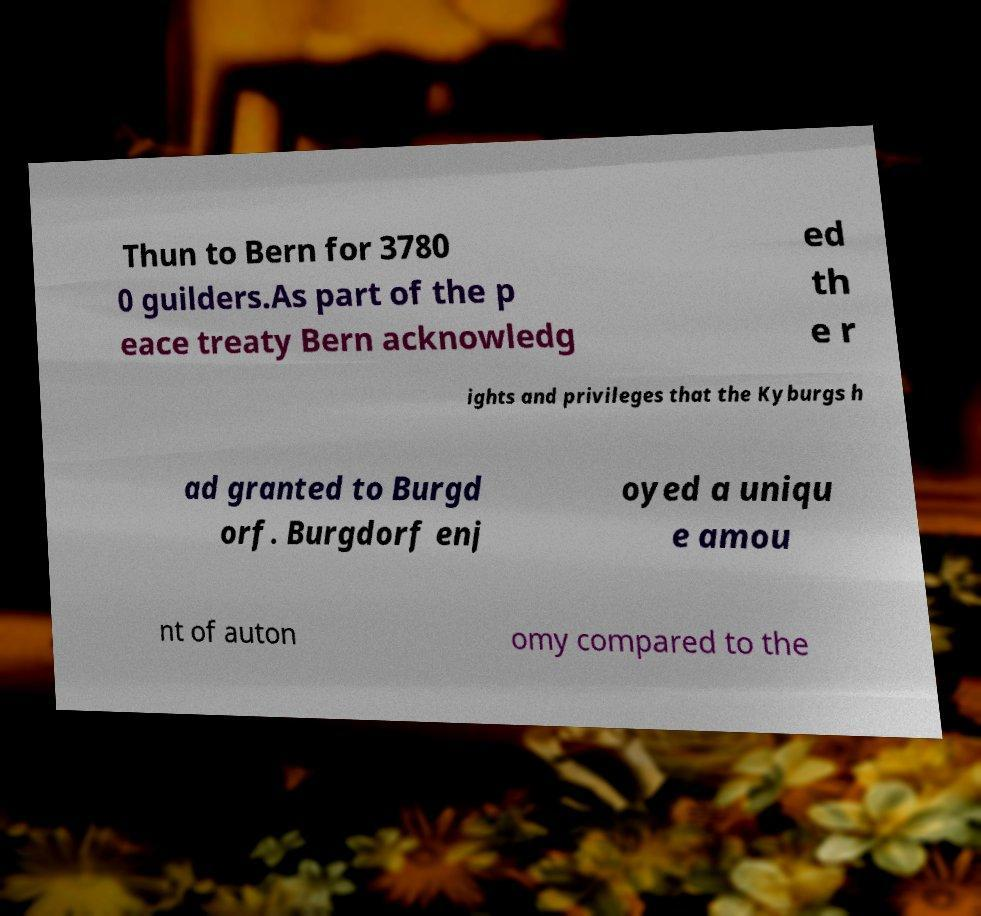What messages or text are displayed in this image? I need them in a readable, typed format. Thun to Bern for 3780 0 guilders.As part of the p eace treaty Bern acknowledg ed th e r ights and privileges that the Kyburgs h ad granted to Burgd orf. Burgdorf enj oyed a uniqu e amou nt of auton omy compared to the 